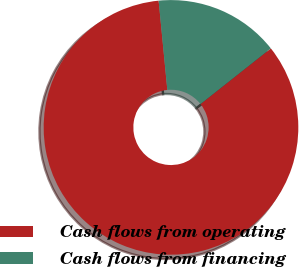Convert chart. <chart><loc_0><loc_0><loc_500><loc_500><pie_chart><fcel>Cash flows from operating<fcel>Cash flows from financing<nl><fcel>84.11%<fcel>15.89%<nl></chart> 